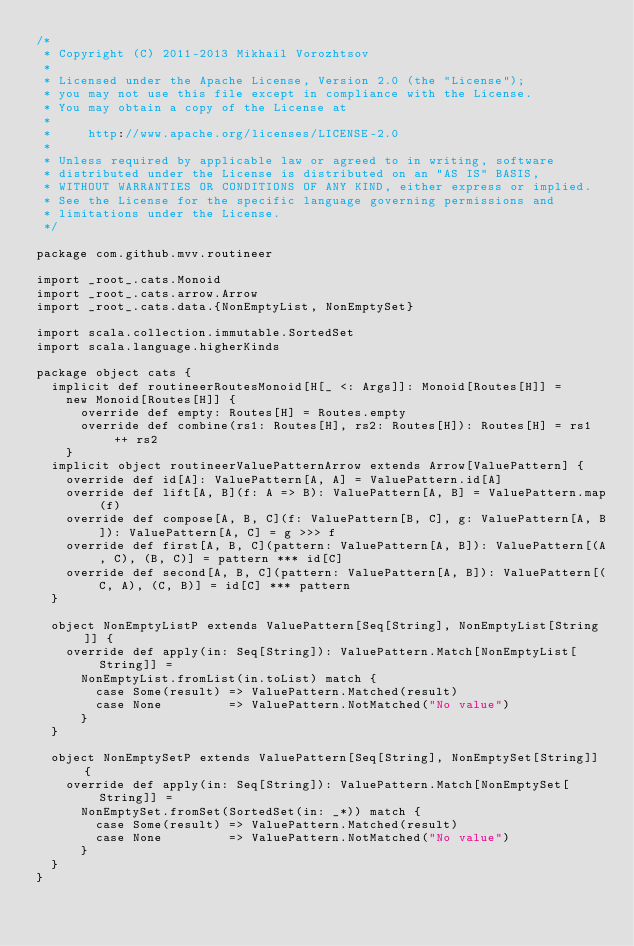Convert code to text. <code><loc_0><loc_0><loc_500><loc_500><_Scala_>/*
 * Copyright (C) 2011-2013 Mikhail Vorozhtsov
 *
 * Licensed under the Apache License, Version 2.0 (the "License");
 * you may not use this file except in compliance with the License.
 * You may obtain a copy of the License at
 *
 *     http://www.apache.org/licenses/LICENSE-2.0
 *
 * Unless required by applicable law or agreed to in writing, software
 * distributed under the License is distributed on an "AS IS" BASIS,
 * WITHOUT WARRANTIES OR CONDITIONS OF ANY KIND, either express or implied.
 * See the License for the specific language governing permissions and
 * limitations under the License.
 */

package com.github.mvv.routineer

import _root_.cats.Monoid
import _root_.cats.arrow.Arrow
import _root_.cats.data.{NonEmptyList, NonEmptySet}

import scala.collection.immutable.SortedSet
import scala.language.higherKinds

package object cats {
  implicit def routineerRoutesMonoid[H[_ <: Args]]: Monoid[Routes[H]] =
    new Monoid[Routes[H]] {
      override def empty: Routes[H] = Routes.empty
      override def combine(rs1: Routes[H], rs2: Routes[H]): Routes[H] = rs1 ++ rs2
    }
  implicit object routineerValuePatternArrow extends Arrow[ValuePattern] {
    override def id[A]: ValuePattern[A, A] = ValuePattern.id[A]
    override def lift[A, B](f: A => B): ValuePattern[A, B] = ValuePattern.map(f)
    override def compose[A, B, C](f: ValuePattern[B, C], g: ValuePattern[A, B]): ValuePattern[A, C] = g >>> f
    override def first[A, B, C](pattern: ValuePattern[A, B]): ValuePattern[(A, C), (B, C)] = pattern *** id[C]
    override def second[A, B, C](pattern: ValuePattern[A, B]): ValuePattern[(C, A), (C, B)] = id[C] *** pattern
  }

  object NonEmptyListP extends ValuePattern[Seq[String], NonEmptyList[String]] {
    override def apply(in: Seq[String]): ValuePattern.Match[NonEmptyList[String]] =
      NonEmptyList.fromList(in.toList) match {
        case Some(result) => ValuePattern.Matched(result)
        case None         => ValuePattern.NotMatched("No value")
      }
  }

  object NonEmptySetP extends ValuePattern[Seq[String], NonEmptySet[String]] {
    override def apply(in: Seq[String]): ValuePattern.Match[NonEmptySet[String]] =
      NonEmptySet.fromSet(SortedSet(in: _*)) match {
        case Some(result) => ValuePattern.Matched(result)
        case None         => ValuePattern.NotMatched("No value")
      }
  }
}
</code> 